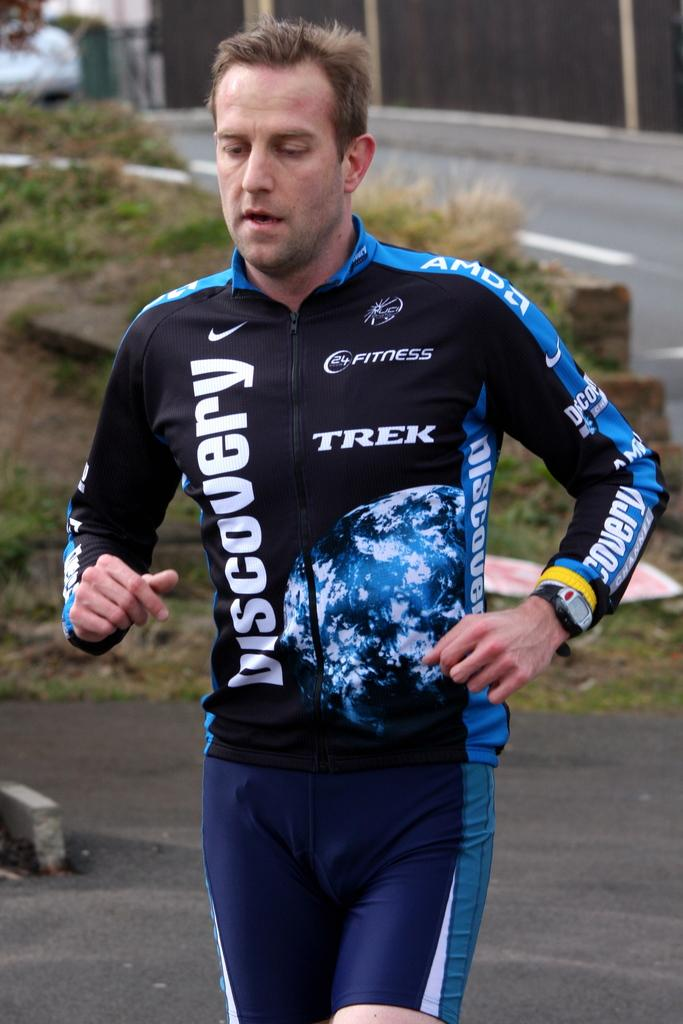What is the person in the image doing? The person is running in the image. Where is the person running? The person is running on a road. What type of natural environment can be seen in the image? There is grass visible in the image. What else can be seen in the image besides the person and the road? There are plants and a building in the image. What type of locket is the person wearing around their neck in the image? There is no locket visible in the image; the person is running and not wearing any jewelry. 